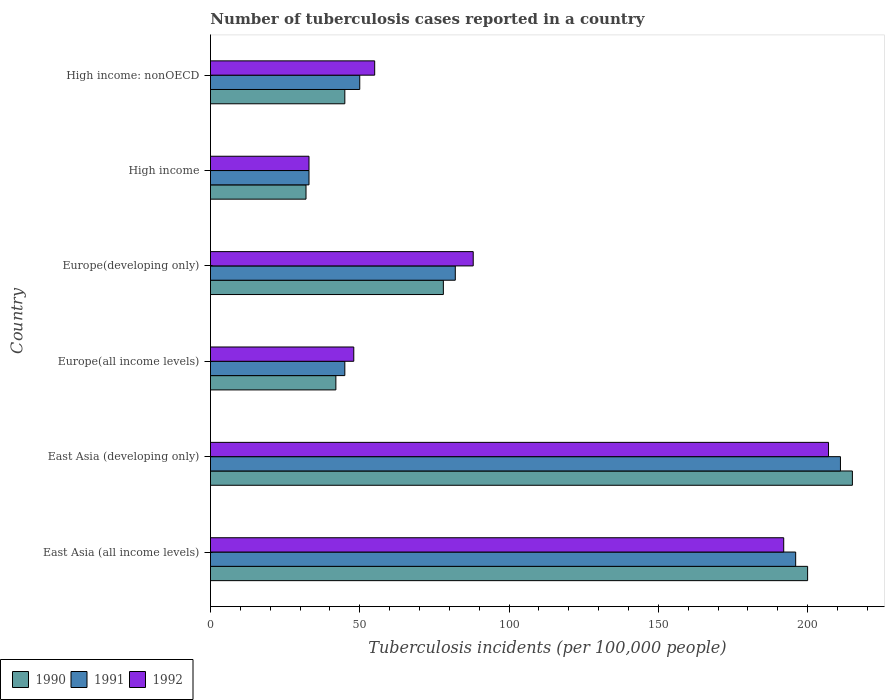How many different coloured bars are there?
Your answer should be compact. 3. How many groups of bars are there?
Your response must be concise. 6. Are the number of bars per tick equal to the number of legend labels?
Provide a short and direct response. Yes. What is the label of the 4th group of bars from the top?
Your response must be concise. Europe(all income levels). Across all countries, what is the maximum number of tuberculosis cases reported in in 1991?
Your answer should be compact. 211. Across all countries, what is the minimum number of tuberculosis cases reported in in 1992?
Your response must be concise. 33. In which country was the number of tuberculosis cases reported in in 1991 maximum?
Provide a succinct answer. East Asia (developing only). What is the total number of tuberculosis cases reported in in 1991 in the graph?
Your answer should be very brief. 617. What is the difference between the number of tuberculosis cases reported in in 1992 in East Asia (developing only) and that in High income: nonOECD?
Offer a terse response. 152. What is the difference between the number of tuberculosis cases reported in in 1990 in Europe(all income levels) and the number of tuberculosis cases reported in in 1992 in High income?
Offer a terse response. 9. What is the average number of tuberculosis cases reported in in 1990 per country?
Your answer should be compact. 102. What is the difference between the number of tuberculosis cases reported in in 1991 and number of tuberculosis cases reported in in 1990 in East Asia (developing only)?
Ensure brevity in your answer.  -4. In how many countries, is the number of tuberculosis cases reported in in 1990 greater than 70 ?
Provide a succinct answer. 3. What is the ratio of the number of tuberculosis cases reported in in 1990 in High income to that in High income: nonOECD?
Offer a very short reply. 0.71. Is the difference between the number of tuberculosis cases reported in in 1991 in Europe(developing only) and High income: nonOECD greater than the difference between the number of tuberculosis cases reported in in 1990 in Europe(developing only) and High income: nonOECD?
Give a very brief answer. No. What is the difference between the highest and the second highest number of tuberculosis cases reported in in 1991?
Your response must be concise. 15. What is the difference between the highest and the lowest number of tuberculosis cases reported in in 1992?
Your answer should be very brief. 174. Is the sum of the number of tuberculosis cases reported in in 1992 in Europe(all income levels) and High income: nonOECD greater than the maximum number of tuberculosis cases reported in in 1991 across all countries?
Your answer should be compact. No. What does the 3rd bar from the bottom in East Asia (developing only) represents?
Give a very brief answer. 1992. Is it the case that in every country, the sum of the number of tuberculosis cases reported in in 1990 and number of tuberculosis cases reported in in 1992 is greater than the number of tuberculosis cases reported in in 1991?
Offer a very short reply. Yes. How many bars are there?
Offer a very short reply. 18. How many countries are there in the graph?
Provide a succinct answer. 6. What is the difference between two consecutive major ticks on the X-axis?
Offer a terse response. 50. Does the graph contain grids?
Give a very brief answer. No. What is the title of the graph?
Offer a very short reply. Number of tuberculosis cases reported in a country. Does "1992" appear as one of the legend labels in the graph?
Make the answer very short. Yes. What is the label or title of the X-axis?
Provide a short and direct response. Tuberculosis incidents (per 100,0 people). What is the Tuberculosis incidents (per 100,000 people) in 1991 in East Asia (all income levels)?
Your answer should be compact. 196. What is the Tuberculosis incidents (per 100,000 people) of 1992 in East Asia (all income levels)?
Ensure brevity in your answer.  192. What is the Tuberculosis incidents (per 100,000 people) of 1990 in East Asia (developing only)?
Offer a very short reply. 215. What is the Tuberculosis incidents (per 100,000 people) of 1991 in East Asia (developing only)?
Give a very brief answer. 211. What is the Tuberculosis incidents (per 100,000 people) in 1992 in East Asia (developing only)?
Make the answer very short. 207. What is the Tuberculosis incidents (per 100,000 people) in 1992 in Europe(all income levels)?
Offer a terse response. 48. What is the Tuberculosis incidents (per 100,000 people) in 1990 in Europe(developing only)?
Provide a short and direct response. 78. What is the Tuberculosis incidents (per 100,000 people) of 1991 in Europe(developing only)?
Your response must be concise. 82. What is the Tuberculosis incidents (per 100,000 people) of 1990 in High income?
Offer a very short reply. 32. What is the Tuberculosis incidents (per 100,000 people) in 1992 in High income?
Provide a short and direct response. 33. Across all countries, what is the maximum Tuberculosis incidents (per 100,000 people) in 1990?
Offer a very short reply. 215. Across all countries, what is the maximum Tuberculosis incidents (per 100,000 people) of 1991?
Your response must be concise. 211. Across all countries, what is the maximum Tuberculosis incidents (per 100,000 people) in 1992?
Keep it short and to the point. 207. What is the total Tuberculosis incidents (per 100,000 people) in 1990 in the graph?
Your answer should be very brief. 612. What is the total Tuberculosis incidents (per 100,000 people) of 1991 in the graph?
Make the answer very short. 617. What is the total Tuberculosis incidents (per 100,000 people) of 1992 in the graph?
Offer a very short reply. 623. What is the difference between the Tuberculosis incidents (per 100,000 people) of 1991 in East Asia (all income levels) and that in East Asia (developing only)?
Provide a short and direct response. -15. What is the difference between the Tuberculosis incidents (per 100,000 people) in 1992 in East Asia (all income levels) and that in East Asia (developing only)?
Make the answer very short. -15. What is the difference between the Tuberculosis incidents (per 100,000 people) in 1990 in East Asia (all income levels) and that in Europe(all income levels)?
Provide a succinct answer. 158. What is the difference between the Tuberculosis incidents (per 100,000 people) in 1991 in East Asia (all income levels) and that in Europe(all income levels)?
Provide a short and direct response. 151. What is the difference between the Tuberculosis incidents (per 100,000 people) in 1992 in East Asia (all income levels) and that in Europe(all income levels)?
Make the answer very short. 144. What is the difference between the Tuberculosis incidents (per 100,000 people) in 1990 in East Asia (all income levels) and that in Europe(developing only)?
Offer a terse response. 122. What is the difference between the Tuberculosis incidents (per 100,000 people) of 1991 in East Asia (all income levels) and that in Europe(developing only)?
Provide a succinct answer. 114. What is the difference between the Tuberculosis incidents (per 100,000 people) in 1992 in East Asia (all income levels) and that in Europe(developing only)?
Offer a terse response. 104. What is the difference between the Tuberculosis incidents (per 100,000 people) of 1990 in East Asia (all income levels) and that in High income?
Your answer should be very brief. 168. What is the difference between the Tuberculosis incidents (per 100,000 people) of 1991 in East Asia (all income levels) and that in High income?
Ensure brevity in your answer.  163. What is the difference between the Tuberculosis incidents (per 100,000 people) in 1992 in East Asia (all income levels) and that in High income?
Make the answer very short. 159. What is the difference between the Tuberculosis incidents (per 100,000 people) of 1990 in East Asia (all income levels) and that in High income: nonOECD?
Your answer should be compact. 155. What is the difference between the Tuberculosis incidents (per 100,000 people) in 1991 in East Asia (all income levels) and that in High income: nonOECD?
Your response must be concise. 146. What is the difference between the Tuberculosis incidents (per 100,000 people) of 1992 in East Asia (all income levels) and that in High income: nonOECD?
Offer a terse response. 137. What is the difference between the Tuberculosis incidents (per 100,000 people) in 1990 in East Asia (developing only) and that in Europe(all income levels)?
Your answer should be compact. 173. What is the difference between the Tuberculosis incidents (per 100,000 people) of 1991 in East Asia (developing only) and that in Europe(all income levels)?
Provide a succinct answer. 166. What is the difference between the Tuberculosis incidents (per 100,000 people) of 1992 in East Asia (developing only) and that in Europe(all income levels)?
Make the answer very short. 159. What is the difference between the Tuberculosis incidents (per 100,000 people) of 1990 in East Asia (developing only) and that in Europe(developing only)?
Your answer should be very brief. 137. What is the difference between the Tuberculosis incidents (per 100,000 people) in 1991 in East Asia (developing only) and that in Europe(developing only)?
Your response must be concise. 129. What is the difference between the Tuberculosis incidents (per 100,000 people) in 1992 in East Asia (developing only) and that in Europe(developing only)?
Offer a terse response. 119. What is the difference between the Tuberculosis incidents (per 100,000 people) in 1990 in East Asia (developing only) and that in High income?
Your answer should be very brief. 183. What is the difference between the Tuberculosis incidents (per 100,000 people) of 1991 in East Asia (developing only) and that in High income?
Make the answer very short. 178. What is the difference between the Tuberculosis incidents (per 100,000 people) in 1992 in East Asia (developing only) and that in High income?
Your response must be concise. 174. What is the difference between the Tuberculosis incidents (per 100,000 people) of 1990 in East Asia (developing only) and that in High income: nonOECD?
Provide a short and direct response. 170. What is the difference between the Tuberculosis incidents (per 100,000 people) of 1991 in East Asia (developing only) and that in High income: nonOECD?
Your response must be concise. 161. What is the difference between the Tuberculosis incidents (per 100,000 people) in 1992 in East Asia (developing only) and that in High income: nonOECD?
Ensure brevity in your answer.  152. What is the difference between the Tuberculosis incidents (per 100,000 people) in 1990 in Europe(all income levels) and that in Europe(developing only)?
Provide a short and direct response. -36. What is the difference between the Tuberculosis incidents (per 100,000 people) of 1991 in Europe(all income levels) and that in Europe(developing only)?
Your answer should be compact. -37. What is the difference between the Tuberculosis incidents (per 100,000 people) of 1992 in Europe(all income levels) and that in Europe(developing only)?
Your answer should be very brief. -40. What is the difference between the Tuberculosis incidents (per 100,000 people) in 1991 in Europe(all income levels) and that in High income?
Provide a short and direct response. 12. What is the difference between the Tuberculosis incidents (per 100,000 people) in 1991 in Europe(developing only) and that in High income?
Ensure brevity in your answer.  49. What is the difference between the Tuberculosis incidents (per 100,000 people) in 1992 in Europe(developing only) and that in High income: nonOECD?
Offer a very short reply. 33. What is the difference between the Tuberculosis incidents (per 100,000 people) in 1990 in East Asia (all income levels) and the Tuberculosis incidents (per 100,000 people) in 1991 in Europe(all income levels)?
Provide a short and direct response. 155. What is the difference between the Tuberculosis incidents (per 100,000 people) in 1990 in East Asia (all income levels) and the Tuberculosis incidents (per 100,000 people) in 1992 in Europe(all income levels)?
Offer a very short reply. 152. What is the difference between the Tuberculosis incidents (per 100,000 people) of 1991 in East Asia (all income levels) and the Tuberculosis incidents (per 100,000 people) of 1992 in Europe(all income levels)?
Provide a short and direct response. 148. What is the difference between the Tuberculosis incidents (per 100,000 people) in 1990 in East Asia (all income levels) and the Tuberculosis incidents (per 100,000 people) in 1991 in Europe(developing only)?
Make the answer very short. 118. What is the difference between the Tuberculosis incidents (per 100,000 people) of 1990 in East Asia (all income levels) and the Tuberculosis incidents (per 100,000 people) of 1992 in Europe(developing only)?
Provide a succinct answer. 112. What is the difference between the Tuberculosis incidents (per 100,000 people) in 1991 in East Asia (all income levels) and the Tuberculosis incidents (per 100,000 people) in 1992 in Europe(developing only)?
Provide a succinct answer. 108. What is the difference between the Tuberculosis incidents (per 100,000 people) in 1990 in East Asia (all income levels) and the Tuberculosis incidents (per 100,000 people) in 1991 in High income?
Offer a terse response. 167. What is the difference between the Tuberculosis incidents (per 100,000 people) in 1990 in East Asia (all income levels) and the Tuberculosis incidents (per 100,000 people) in 1992 in High income?
Your answer should be compact. 167. What is the difference between the Tuberculosis incidents (per 100,000 people) of 1991 in East Asia (all income levels) and the Tuberculosis incidents (per 100,000 people) of 1992 in High income?
Provide a short and direct response. 163. What is the difference between the Tuberculosis incidents (per 100,000 people) in 1990 in East Asia (all income levels) and the Tuberculosis incidents (per 100,000 people) in 1991 in High income: nonOECD?
Your response must be concise. 150. What is the difference between the Tuberculosis incidents (per 100,000 people) of 1990 in East Asia (all income levels) and the Tuberculosis incidents (per 100,000 people) of 1992 in High income: nonOECD?
Keep it short and to the point. 145. What is the difference between the Tuberculosis incidents (per 100,000 people) in 1991 in East Asia (all income levels) and the Tuberculosis incidents (per 100,000 people) in 1992 in High income: nonOECD?
Ensure brevity in your answer.  141. What is the difference between the Tuberculosis incidents (per 100,000 people) in 1990 in East Asia (developing only) and the Tuberculosis incidents (per 100,000 people) in 1991 in Europe(all income levels)?
Your answer should be very brief. 170. What is the difference between the Tuberculosis incidents (per 100,000 people) in 1990 in East Asia (developing only) and the Tuberculosis incidents (per 100,000 people) in 1992 in Europe(all income levels)?
Keep it short and to the point. 167. What is the difference between the Tuberculosis incidents (per 100,000 people) in 1991 in East Asia (developing only) and the Tuberculosis incidents (per 100,000 people) in 1992 in Europe(all income levels)?
Make the answer very short. 163. What is the difference between the Tuberculosis incidents (per 100,000 people) of 1990 in East Asia (developing only) and the Tuberculosis incidents (per 100,000 people) of 1991 in Europe(developing only)?
Your answer should be compact. 133. What is the difference between the Tuberculosis incidents (per 100,000 people) of 1990 in East Asia (developing only) and the Tuberculosis incidents (per 100,000 people) of 1992 in Europe(developing only)?
Your response must be concise. 127. What is the difference between the Tuberculosis incidents (per 100,000 people) of 1991 in East Asia (developing only) and the Tuberculosis incidents (per 100,000 people) of 1992 in Europe(developing only)?
Keep it short and to the point. 123. What is the difference between the Tuberculosis incidents (per 100,000 people) of 1990 in East Asia (developing only) and the Tuberculosis incidents (per 100,000 people) of 1991 in High income?
Keep it short and to the point. 182. What is the difference between the Tuberculosis incidents (per 100,000 people) of 1990 in East Asia (developing only) and the Tuberculosis incidents (per 100,000 people) of 1992 in High income?
Ensure brevity in your answer.  182. What is the difference between the Tuberculosis incidents (per 100,000 people) of 1991 in East Asia (developing only) and the Tuberculosis incidents (per 100,000 people) of 1992 in High income?
Your answer should be compact. 178. What is the difference between the Tuberculosis incidents (per 100,000 people) in 1990 in East Asia (developing only) and the Tuberculosis incidents (per 100,000 people) in 1991 in High income: nonOECD?
Your answer should be very brief. 165. What is the difference between the Tuberculosis incidents (per 100,000 people) of 1990 in East Asia (developing only) and the Tuberculosis incidents (per 100,000 people) of 1992 in High income: nonOECD?
Keep it short and to the point. 160. What is the difference between the Tuberculosis incidents (per 100,000 people) in 1991 in East Asia (developing only) and the Tuberculosis incidents (per 100,000 people) in 1992 in High income: nonOECD?
Provide a short and direct response. 156. What is the difference between the Tuberculosis incidents (per 100,000 people) of 1990 in Europe(all income levels) and the Tuberculosis incidents (per 100,000 people) of 1991 in Europe(developing only)?
Provide a short and direct response. -40. What is the difference between the Tuberculosis incidents (per 100,000 people) of 1990 in Europe(all income levels) and the Tuberculosis incidents (per 100,000 people) of 1992 in Europe(developing only)?
Your answer should be compact. -46. What is the difference between the Tuberculosis incidents (per 100,000 people) of 1991 in Europe(all income levels) and the Tuberculosis incidents (per 100,000 people) of 1992 in Europe(developing only)?
Ensure brevity in your answer.  -43. What is the difference between the Tuberculosis incidents (per 100,000 people) of 1991 in Europe(all income levels) and the Tuberculosis incidents (per 100,000 people) of 1992 in High income?
Make the answer very short. 12. What is the difference between the Tuberculosis incidents (per 100,000 people) of 1990 in Europe(all income levels) and the Tuberculosis incidents (per 100,000 people) of 1992 in High income: nonOECD?
Offer a terse response. -13. What is the difference between the Tuberculosis incidents (per 100,000 people) in 1990 in Europe(developing only) and the Tuberculosis incidents (per 100,000 people) in 1991 in High income?
Provide a short and direct response. 45. What is the difference between the Tuberculosis incidents (per 100,000 people) of 1990 in Europe(developing only) and the Tuberculosis incidents (per 100,000 people) of 1992 in High income: nonOECD?
Offer a terse response. 23. What is the difference between the Tuberculosis incidents (per 100,000 people) in 1991 in Europe(developing only) and the Tuberculosis incidents (per 100,000 people) in 1992 in High income: nonOECD?
Keep it short and to the point. 27. What is the difference between the Tuberculosis incidents (per 100,000 people) of 1991 in High income and the Tuberculosis incidents (per 100,000 people) of 1992 in High income: nonOECD?
Your response must be concise. -22. What is the average Tuberculosis incidents (per 100,000 people) of 1990 per country?
Make the answer very short. 102. What is the average Tuberculosis incidents (per 100,000 people) of 1991 per country?
Ensure brevity in your answer.  102.83. What is the average Tuberculosis incidents (per 100,000 people) of 1992 per country?
Keep it short and to the point. 103.83. What is the difference between the Tuberculosis incidents (per 100,000 people) of 1990 and Tuberculosis incidents (per 100,000 people) of 1991 in East Asia (developing only)?
Make the answer very short. 4. What is the difference between the Tuberculosis incidents (per 100,000 people) in 1990 and Tuberculosis incidents (per 100,000 people) in 1992 in East Asia (developing only)?
Offer a very short reply. 8. What is the difference between the Tuberculosis incidents (per 100,000 people) in 1991 and Tuberculosis incidents (per 100,000 people) in 1992 in Europe(all income levels)?
Your answer should be compact. -3. What is the difference between the Tuberculosis incidents (per 100,000 people) in 1990 and Tuberculosis incidents (per 100,000 people) in 1991 in Europe(developing only)?
Provide a short and direct response. -4. What is the difference between the Tuberculosis incidents (per 100,000 people) of 1991 and Tuberculosis incidents (per 100,000 people) of 1992 in Europe(developing only)?
Give a very brief answer. -6. What is the difference between the Tuberculosis incidents (per 100,000 people) of 1990 and Tuberculosis incidents (per 100,000 people) of 1991 in High income?
Offer a terse response. -1. What is the difference between the Tuberculosis incidents (per 100,000 people) of 1990 and Tuberculosis incidents (per 100,000 people) of 1992 in High income?
Your answer should be very brief. -1. What is the difference between the Tuberculosis incidents (per 100,000 people) of 1991 and Tuberculosis incidents (per 100,000 people) of 1992 in High income?
Offer a terse response. 0. What is the difference between the Tuberculosis incidents (per 100,000 people) in 1990 and Tuberculosis incidents (per 100,000 people) in 1991 in High income: nonOECD?
Offer a very short reply. -5. What is the difference between the Tuberculosis incidents (per 100,000 people) of 1990 and Tuberculosis incidents (per 100,000 people) of 1992 in High income: nonOECD?
Your answer should be very brief. -10. What is the ratio of the Tuberculosis incidents (per 100,000 people) of 1990 in East Asia (all income levels) to that in East Asia (developing only)?
Your response must be concise. 0.93. What is the ratio of the Tuberculosis incidents (per 100,000 people) in 1991 in East Asia (all income levels) to that in East Asia (developing only)?
Keep it short and to the point. 0.93. What is the ratio of the Tuberculosis incidents (per 100,000 people) in 1992 in East Asia (all income levels) to that in East Asia (developing only)?
Provide a short and direct response. 0.93. What is the ratio of the Tuberculosis incidents (per 100,000 people) of 1990 in East Asia (all income levels) to that in Europe(all income levels)?
Provide a succinct answer. 4.76. What is the ratio of the Tuberculosis incidents (per 100,000 people) in 1991 in East Asia (all income levels) to that in Europe(all income levels)?
Keep it short and to the point. 4.36. What is the ratio of the Tuberculosis incidents (per 100,000 people) in 1992 in East Asia (all income levels) to that in Europe(all income levels)?
Give a very brief answer. 4. What is the ratio of the Tuberculosis incidents (per 100,000 people) of 1990 in East Asia (all income levels) to that in Europe(developing only)?
Your answer should be very brief. 2.56. What is the ratio of the Tuberculosis incidents (per 100,000 people) in 1991 in East Asia (all income levels) to that in Europe(developing only)?
Give a very brief answer. 2.39. What is the ratio of the Tuberculosis incidents (per 100,000 people) of 1992 in East Asia (all income levels) to that in Europe(developing only)?
Ensure brevity in your answer.  2.18. What is the ratio of the Tuberculosis incidents (per 100,000 people) of 1990 in East Asia (all income levels) to that in High income?
Offer a terse response. 6.25. What is the ratio of the Tuberculosis incidents (per 100,000 people) of 1991 in East Asia (all income levels) to that in High income?
Your answer should be very brief. 5.94. What is the ratio of the Tuberculosis incidents (per 100,000 people) of 1992 in East Asia (all income levels) to that in High income?
Offer a very short reply. 5.82. What is the ratio of the Tuberculosis incidents (per 100,000 people) in 1990 in East Asia (all income levels) to that in High income: nonOECD?
Ensure brevity in your answer.  4.44. What is the ratio of the Tuberculosis incidents (per 100,000 people) in 1991 in East Asia (all income levels) to that in High income: nonOECD?
Provide a short and direct response. 3.92. What is the ratio of the Tuberculosis incidents (per 100,000 people) in 1992 in East Asia (all income levels) to that in High income: nonOECD?
Give a very brief answer. 3.49. What is the ratio of the Tuberculosis incidents (per 100,000 people) in 1990 in East Asia (developing only) to that in Europe(all income levels)?
Make the answer very short. 5.12. What is the ratio of the Tuberculosis incidents (per 100,000 people) in 1991 in East Asia (developing only) to that in Europe(all income levels)?
Your answer should be very brief. 4.69. What is the ratio of the Tuberculosis incidents (per 100,000 people) in 1992 in East Asia (developing only) to that in Europe(all income levels)?
Provide a short and direct response. 4.31. What is the ratio of the Tuberculosis incidents (per 100,000 people) in 1990 in East Asia (developing only) to that in Europe(developing only)?
Provide a succinct answer. 2.76. What is the ratio of the Tuberculosis incidents (per 100,000 people) in 1991 in East Asia (developing only) to that in Europe(developing only)?
Give a very brief answer. 2.57. What is the ratio of the Tuberculosis incidents (per 100,000 people) in 1992 in East Asia (developing only) to that in Europe(developing only)?
Offer a very short reply. 2.35. What is the ratio of the Tuberculosis incidents (per 100,000 people) of 1990 in East Asia (developing only) to that in High income?
Offer a very short reply. 6.72. What is the ratio of the Tuberculosis incidents (per 100,000 people) in 1991 in East Asia (developing only) to that in High income?
Your answer should be compact. 6.39. What is the ratio of the Tuberculosis incidents (per 100,000 people) of 1992 in East Asia (developing only) to that in High income?
Make the answer very short. 6.27. What is the ratio of the Tuberculosis incidents (per 100,000 people) of 1990 in East Asia (developing only) to that in High income: nonOECD?
Provide a short and direct response. 4.78. What is the ratio of the Tuberculosis incidents (per 100,000 people) of 1991 in East Asia (developing only) to that in High income: nonOECD?
Your answer should be compact. 4.22. What is the ratio of the Tuberculosis incidents (per 100,000 people) in 1992 in East Asia (developing only) to that in High income: nonOECD?
Ensure brevity in your answer.  3.76. What is the ratio of the Tuberculosis incidents (per 100,000 people) in 1990 in Europe(all income levels) to that in Europe(developing only)?
Keep it short and to the point. 0.54. What is the ratio of the Tuberculosis incidents (per 100,000 people) of 1991 in Europe(all income levels) to that in Europe(developing only)?
Ensure brevity in your answer.  0.55. What is the ratio of the Tuberculosis incidents (per 100,000 people) in 1992 in Europe(all income levels) to that in Europe(developing only)?
Give a very brief answer. 0.55. What is the ratio of the Tuberculosis incidents (per 100,000 people) of 1990 in Europe(all income levels) to that in High income?
Offer a very short reply. 1.31. What is the ratio of the Tuberculosis incidents (per 100,000 people) of 1991 in Europe(all income levels) to that in High income?
Make the answer very short. 1.36. What is the ratio of the Tuberculosis incidents (per 100,000 people) of 1992 in Europe(all income levels) to that in High income?
Give a very brief answer. 1.45. What is the ratio of the Tuberculosis incidents (per 100,000 people) of 1990 in Europe(all income levels) to that in High income: nonOECD?
Keep it short and to the point. 0.93. What is the ratio of the Tuberculosis incidents (per 100,000 people) of 1991 in Europe(all income levels) to that in High income: nonOECD?
Your answer should be very brief. 0.9. What is the ratio of the Tuberculosis incidents (per 100,000 people) of 1992 in Europe(all income levels) to that in High income: nonOECD?
Offer a terse response. 0.87. What is the ratio of the Tuberculosis incidents (per 100,000 people) in 1990 in Europe(developing only) to that in High income?
Your answer should be compact. 2.44. What is the ratio of the Tuberculosis incidents (per 100,000 people) of 1991 in Europe(developing only) to that in High income?
Make the answer very short. 2.48. What is the ratio of the Tuberculosis incidents (per 100,000 people) of 1992 in Europe(developing only) to that in High income?
Offer a very short reply. 2.67. What is the ratio of the Tuberculosis incidents (per 100,000 people) of 1990 in Europe(developing only) to that in High income: nonOECD?
Your answer should be compact. 1.73. What is the ratio of the Tuberculosis incidents (per 100,000 people) of 1991 in Europe(developing only) to that in High income: nonOECD?
Your answer should be compact. 1.64. What is the ratio of the Tuberculosis incidents (per 100,000 people) in 1992 in Europe(developing only) to that in High income: nonOECD?
Keep it short and to the point. 1.6. What is the ratio of the Tuberculosis incidents (per 100,000 people) of 1990 in High income to that in High income: nonOECD?
Provide a succinct answer. 0.71. What is the ratio of the Tuberculosis incidents (per 100,000 people) in 1991 in High income to that in High income: nonOECD?
Your response must be concise. 0.66. What is the difference between the highest and the lowest Tuberculosis incidents (per 100,000 people) of 1990?
Ensure brevity in your answer.  183. What is the difference between the highest and the lowest Tuberculosis incidents (per 100,000 people) in 1991?
Your answer should be compact. 178. What is the difference between the highest and the lowest Tuberculosis incidents (per 100,000 people) in 1992?
Your answer should be very brief. 174. 